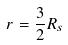Convert formula to latex. <formula><loc_0><loc_0><loc_500><loc_500>r = \frac { 3 } { 2 } R _ { s }</formula> 